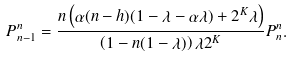Convert formula to latex. <formula><loc_0><loc_0><loc_500><loc_500>P ^ { n } _ { n - 1 } = \frac { n \left ( \alpha ( n - h ) ( 1 - \lambda - \alpha \lambda ) + 2 ^ { K } \lambda \right ) } { \left ( 1 - n ( 1 - \lambda ) \right ) \lambda 2 ^ { K } } P ^ { n } _ { n } .</formula> 